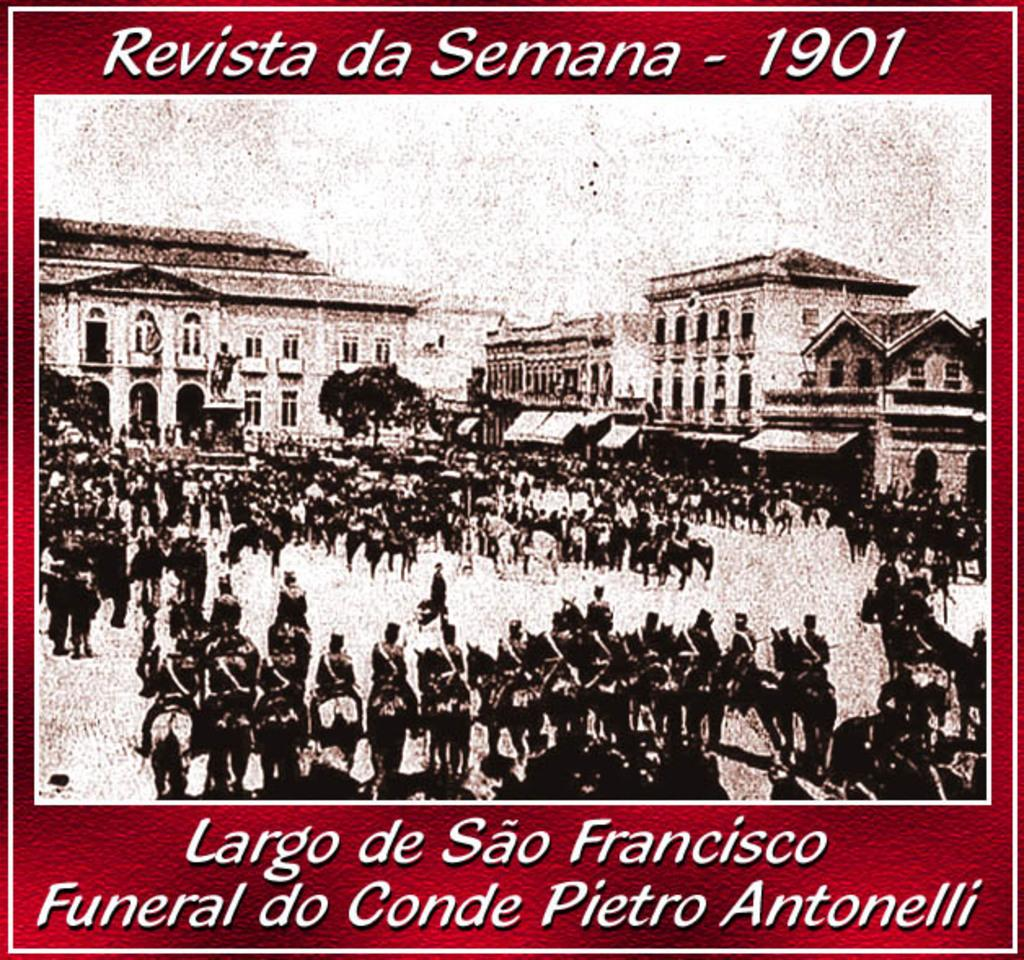Provide a one-sentence caption for the provided image. A 1901 photo of people in a town square. 